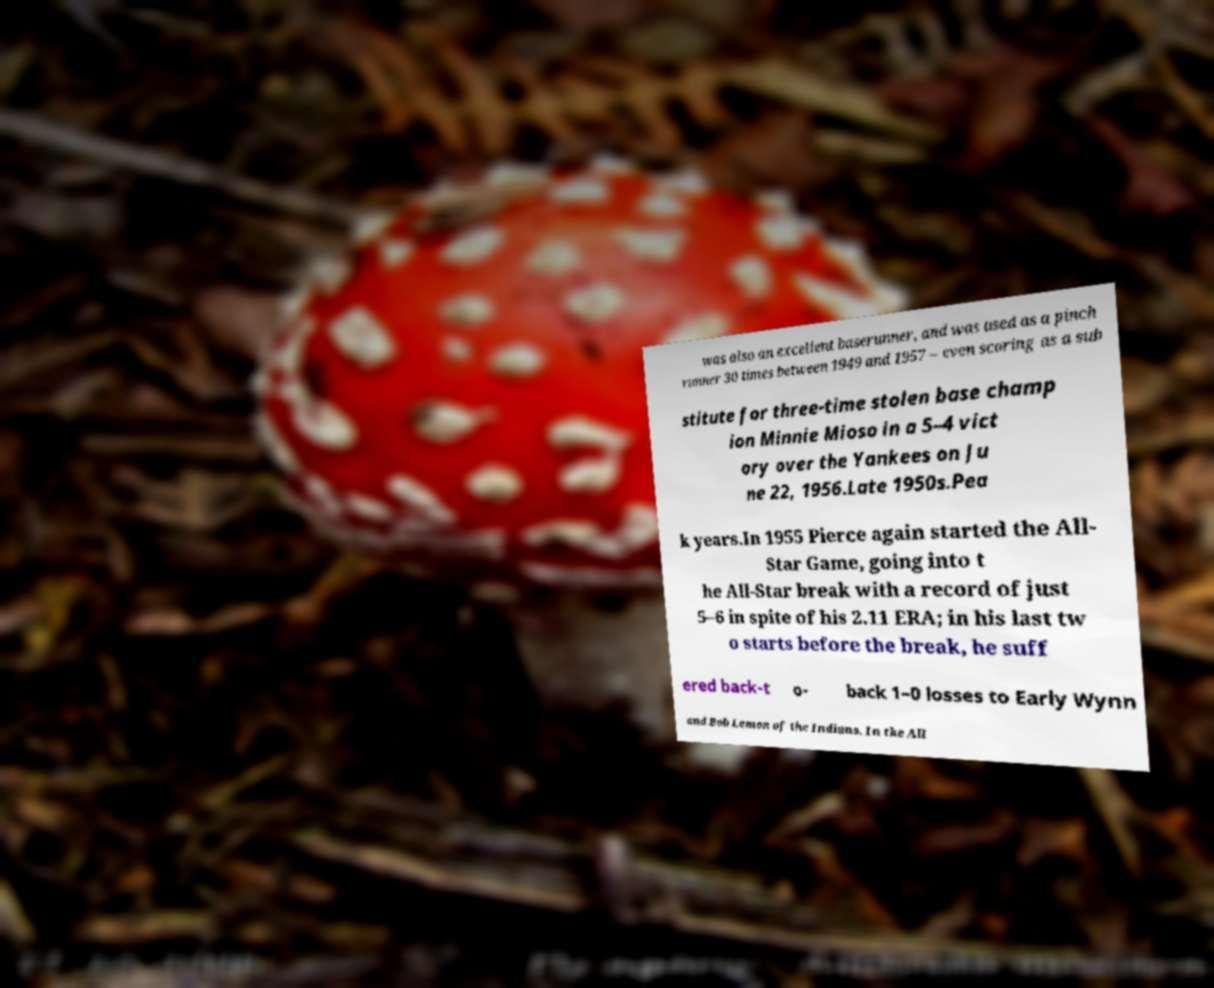Please identify and transcribe the text found in this image. was also an excellent baserunner, and was used as a pinch runner 30 times between 1949 and 1957 – even scoring as a sub stitute for three-time stolen base champ ion Minnie Mioso in a 5–4 vict ory over the Yankees on Ju ne 22, 1956.Late 1950s.Pea k years.In 1955 Pierce again started the All- Star Game, going into t he All-Star break with a record of just 5–6 in spite of his 2.11 ERA; in his last tw o starts before the break, he suff ered back-t o- back 1–0 losses to Early Wynn and Bob Lemon of the Indians. In the All 